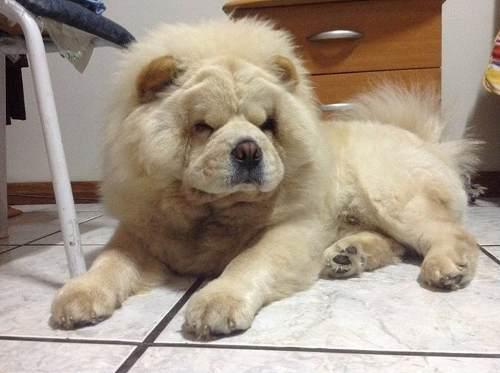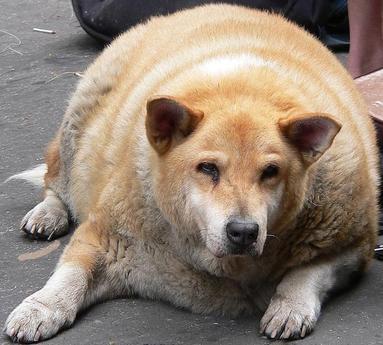The first image is the image on the left, the second image is the image on the right. Analyze the images presented: Is the assertion "Right and left images contain the same number of dogs." valid? Answer yes or no. Yes. The first image is the image on the left, the second image is the image on the right. Considering the images on both sides, is "There are two dogs in total." valid? Answer yes or no. Yes. 